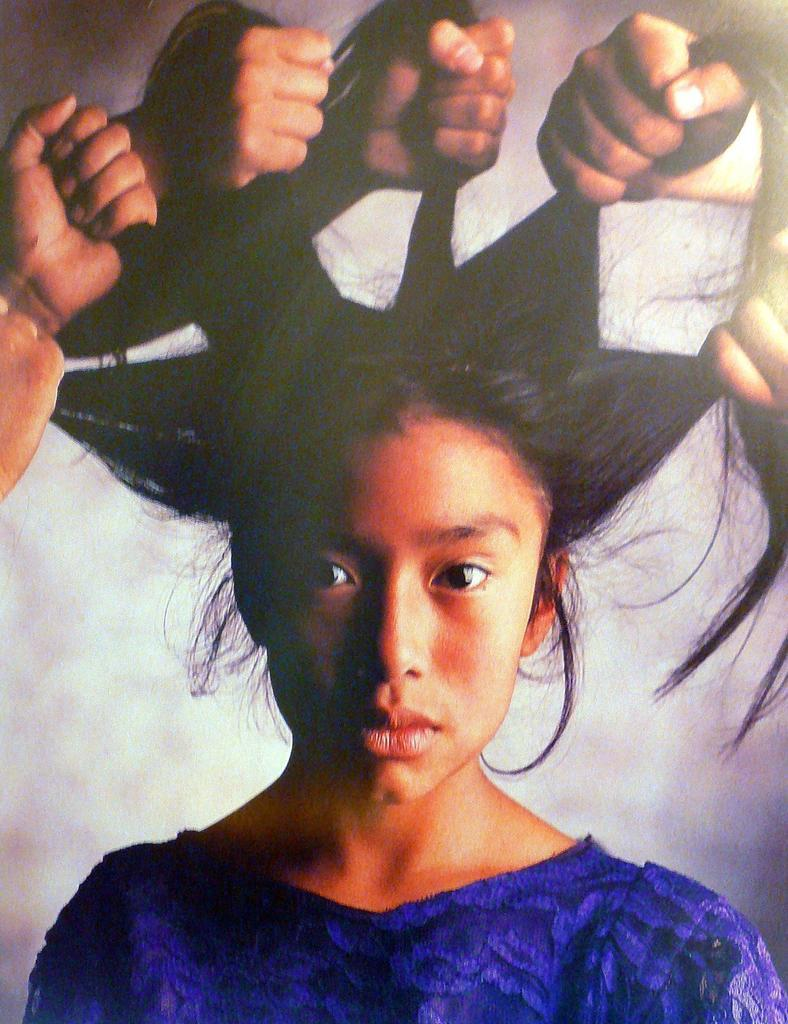Who is the main subject in the image? There is a woman in the image. What are the people in the image doing to the woman? The people in the image are holding the hair of the woman. What type of grip does the woman have on the sand in the image? There is no sand present in the image, and the woman is not gripping anything. 